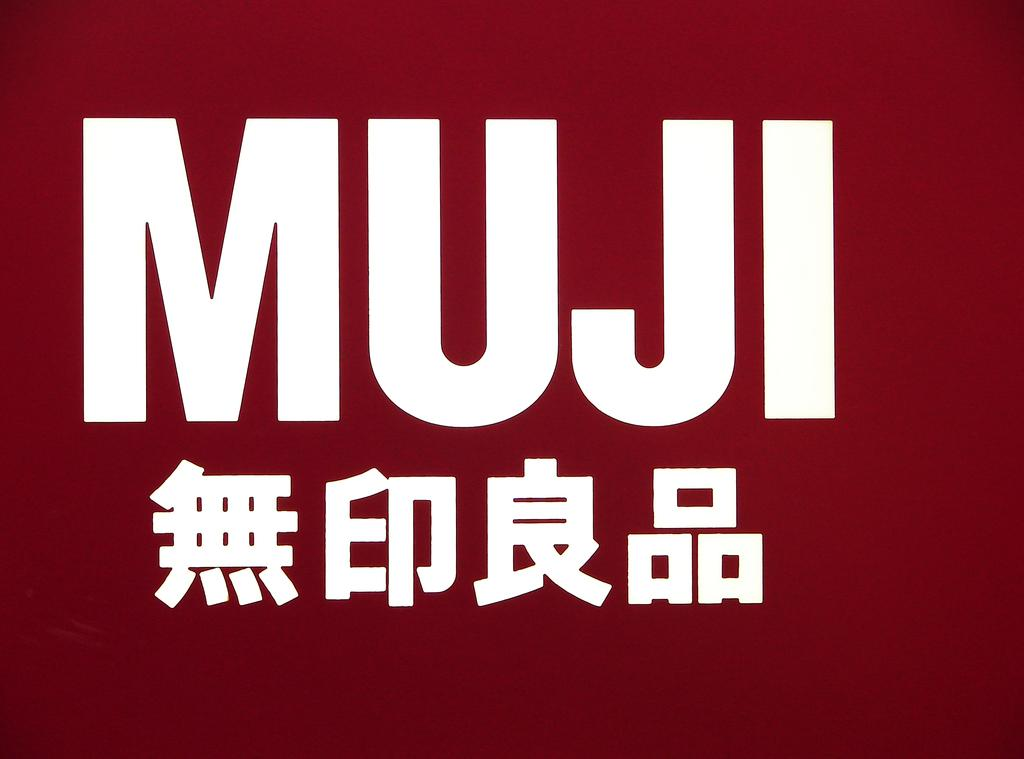Provide a one-sentence caption for the provided image. The red poster has the word MUJI on it. 